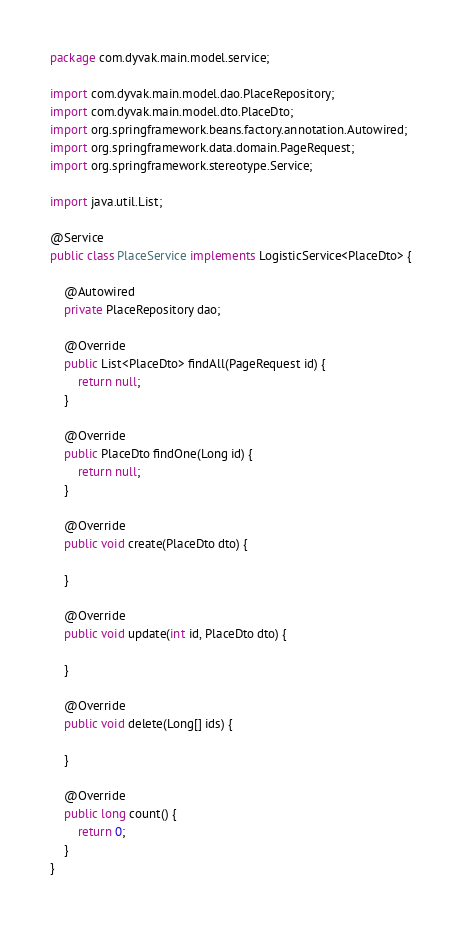Convert code to text. <code><loc_0><loc_0><loc_500><loc_500><_Java_>package com.dyvak.main.model.service;

import com.dyvak.main.model.dao.PlaceRepository;
import com.dyvak.main.model.dto.PlaceDto;
import org.springframework.beans.factory.annotation.Autowired;
import org.springframework.data.domain.PageRequest;
import org.springframework.stereotype.Service;

import java.util.List;

@Service
public class PlaceService implements LogisticService<PlaceDto> {

    @Autowired
    private PlaceRepository dao;

    @Override
    public List<PlaceDto> findAll(PageRequest id) {
        return null;
    }

    @Override
    public PlaceDto findOne(Long id) {
        return null;
    }

    @Override
    public void create(PlaceDto dto) {

    }

    @Override
    public void update(int id, PlaceDto dto) {

    }

    @Override
    public void delete(Long[] ids) {

    }

    @Override
    public long count() {
        return 0;
    }
}
</code> 